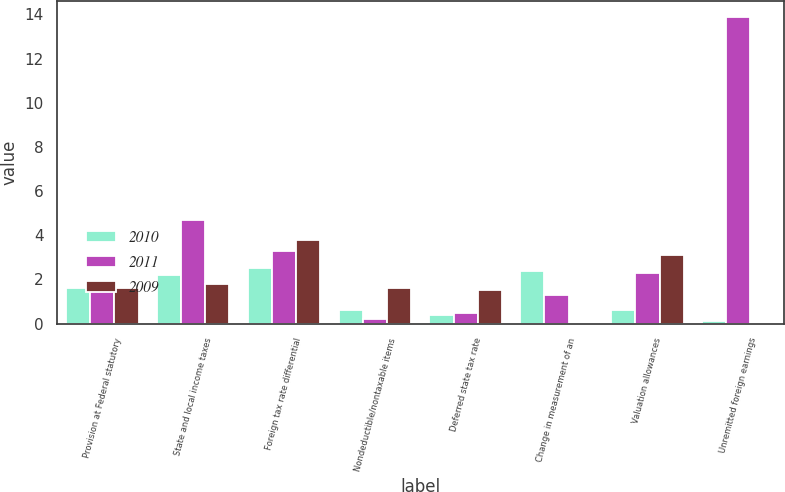<chart> <loc_0><loc_0><loc_500><loc_500><stacked_bar_chart><ecel><fcel>Provision at Federal statutory<fcel>State and local income taxes<fcel>Foreign tax rate differential<fcel>Nondeductible/nontaxable items<fcel>Deferred state tax rate<fcel>Change in measurement of an<fcel>Valuation allowances<fcel>Unremitted foreign earnings<nl><fcel>2010<fcel>1.6<fcel>2.2<fcel>2.5<fcel>0.6<fcel>0.4<fcel>2.4<fcel>0.6<fcel>0.1<nl><fcel>2011<fcel>1.6<fcel>4.7<fcel>3.3<fcel>0.2<fcel>0.5<fcel>1.3<fcel>2.3<fcel>13.9<nl><fcel>2009<fcel>1.6<fcel>1.8<fcel>3.8<fcel>1.6<fcel>1.5<fcel>0<fcel>3.1<fcel>0<nl></chart> 